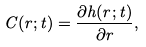<formula> <loc_0><loc_0><loc_500><loc_500>C ( r ; t ) = \frac { \partial h ( r ; t ) } { \partial r } ,</formula> 